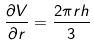Convert formula to latex. <formula><loc_0><loc_0><loc_500><loc_500>\frac { \partial V } { \partial r } = \frac { 2 \pi r h } { 3 }</formula> 